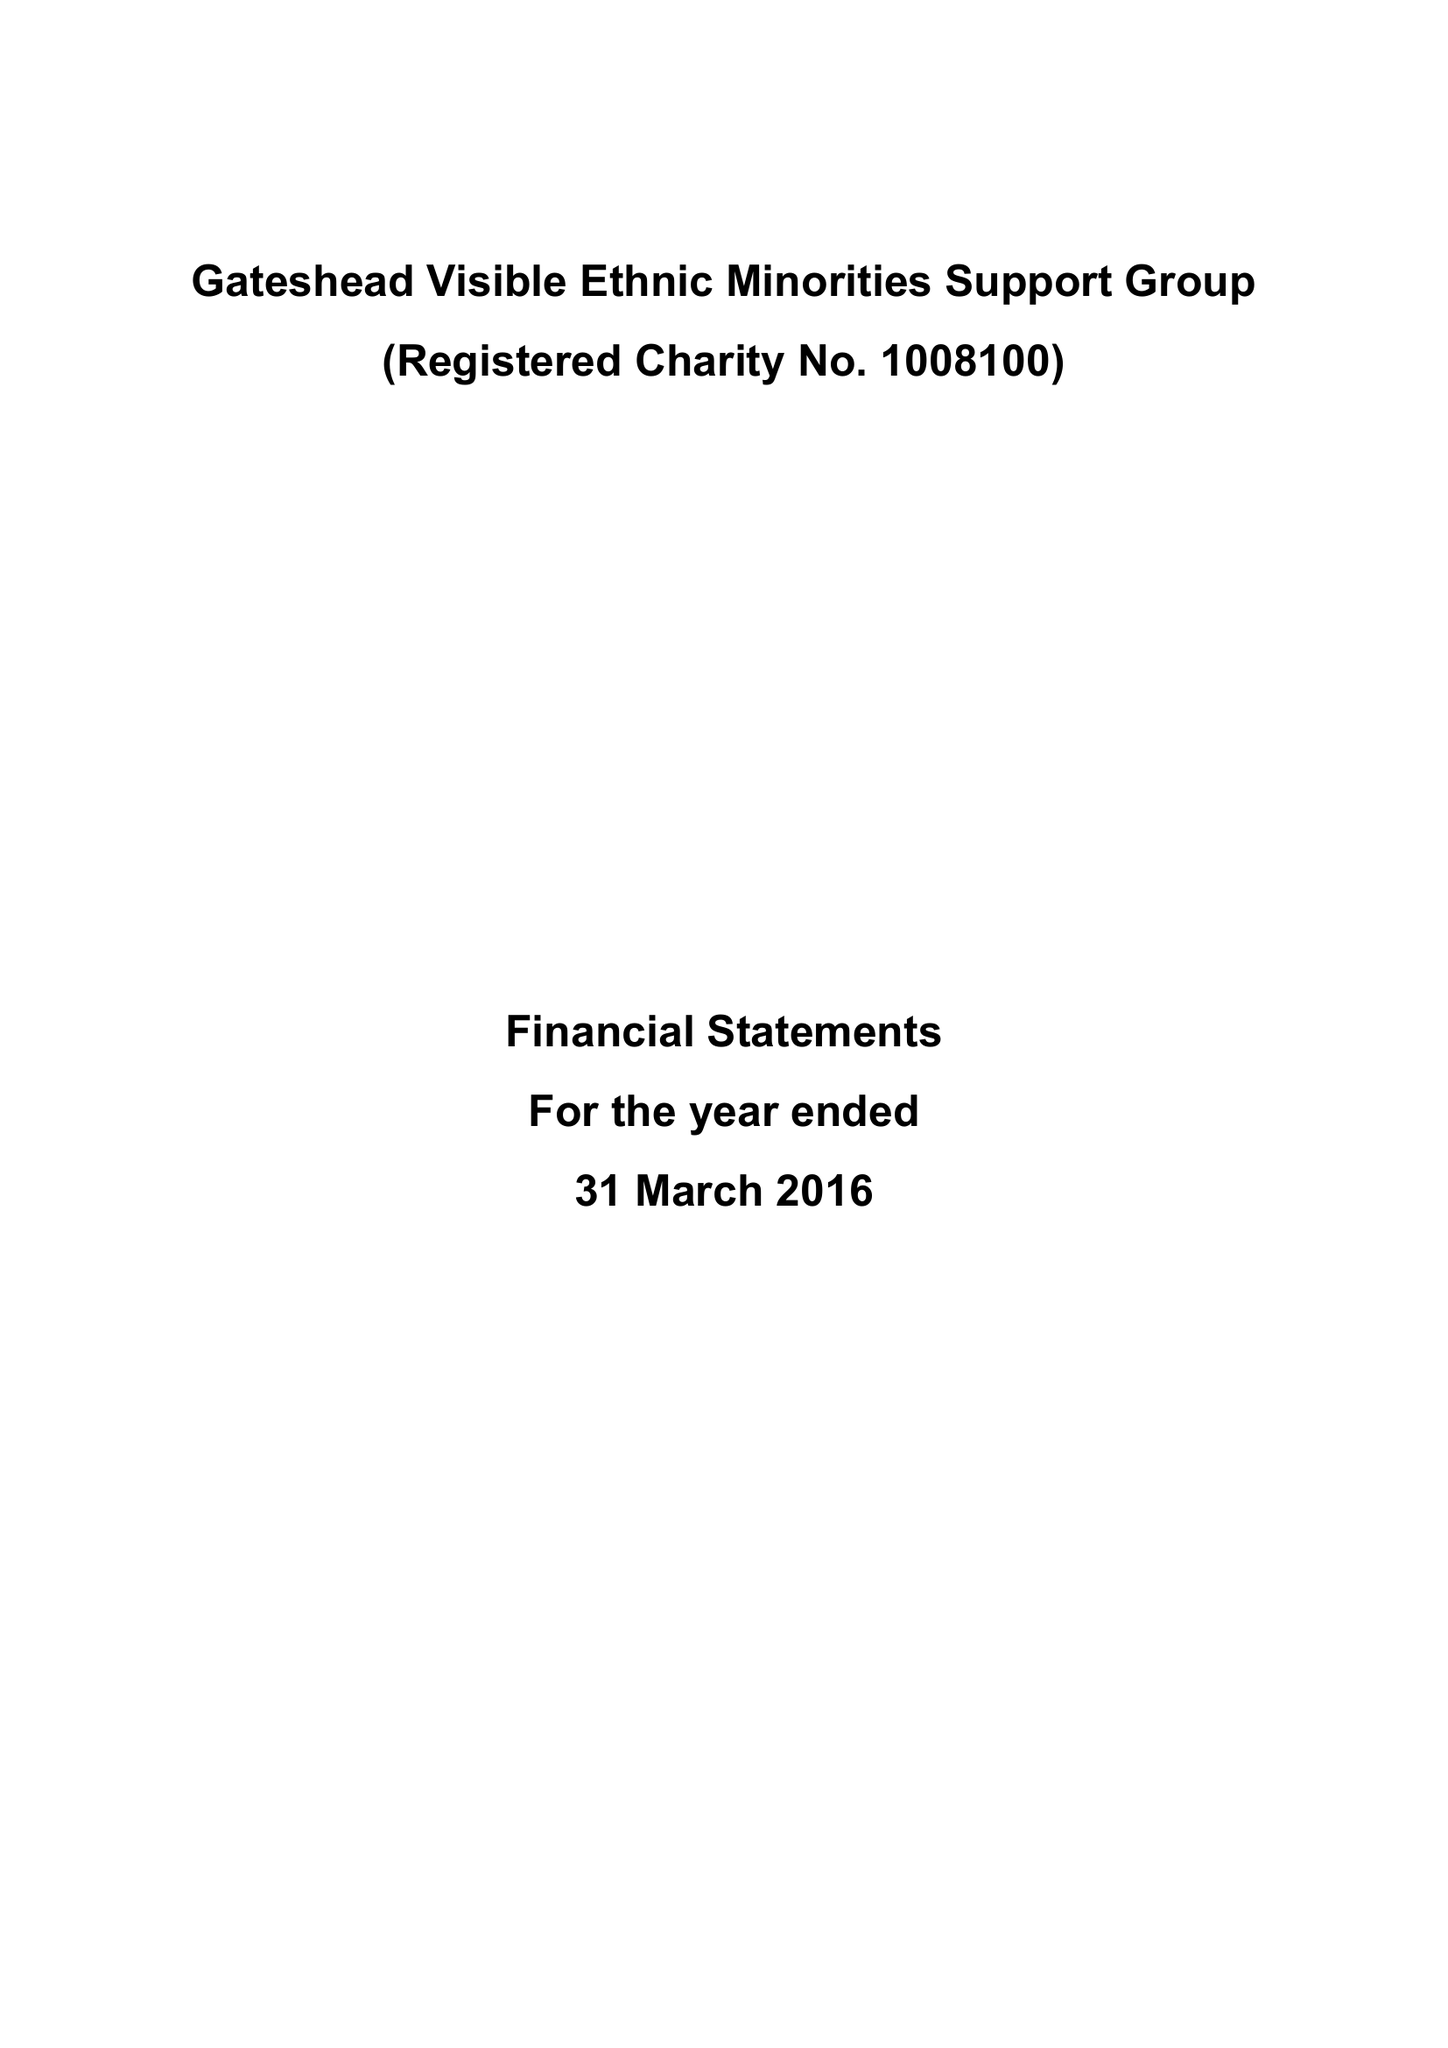What is the value for the report_date?
Answer the question using a single word or phrase. 2016-03-31 